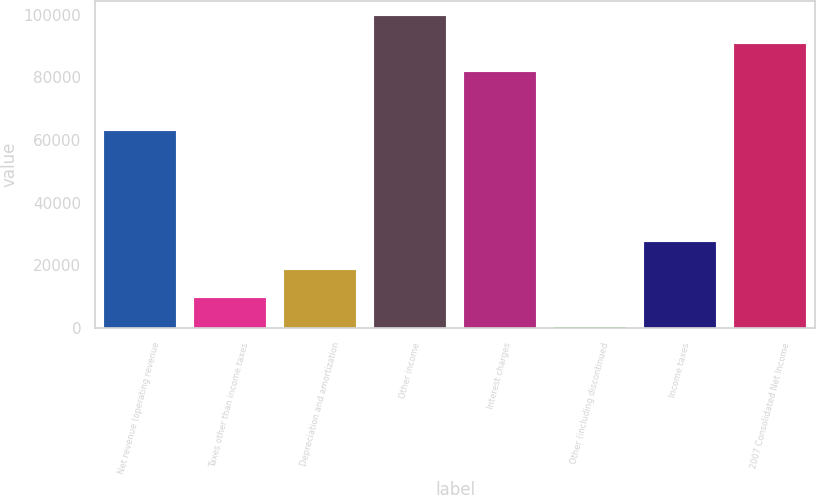Convert chart. <chart><loc_0><loc_0><loc_500><loc_500><bar_chart><fcel>Net revenue (operating revenue<fcel>Taxes other than income taxes<fcel>Depreciation and amortization<fcel>Other income<fcel>Interest charges<fcel>Other (including discontinued<fcel>Income taxes<fcel>2007 Consolidated Net Income<nl><fcel>62994<fcel>9449.9<fcel>18407.8<fcel>99548.8<fcel>81633<fcel>492<fcel>27365.7<fcel>90590.9<nl></chart> 